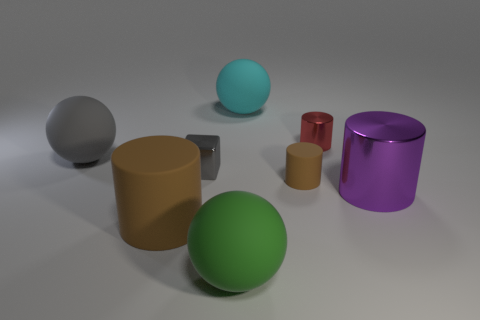Subtract all gray cylinders. Subtract all yellow cubes. How many cylinders are left? 4 Add 1 purple metallic things. How many objects exist? 9 Subtract all blocks. How many objects are left? 7 Add 5 big purple shiny objects. How many big purple shiny objects exist? 6 Subtract 1 purple cylinders. How many objects are left? 7 Subtract all cubes. Subtract all green rubber spheres. How many objects are left? 6 Add 5 large brown cylinders. How many large brown cylinders are left? 6 